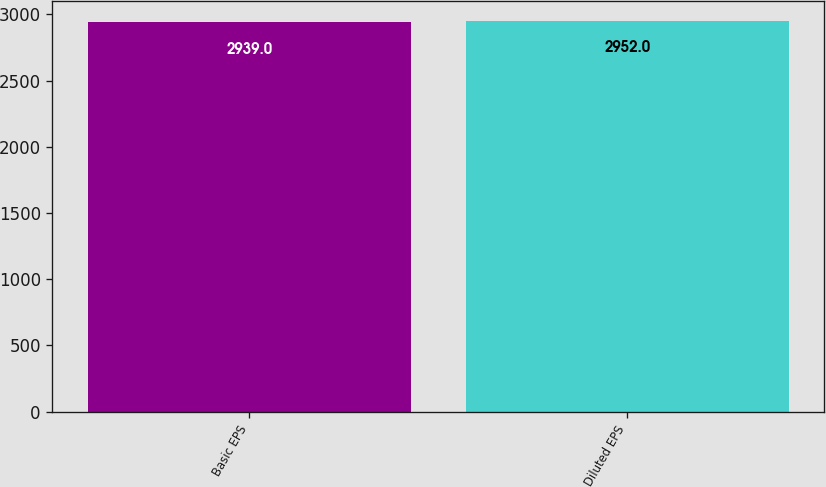Convert chart. <chart><loc_0><loc_0><loc_500><loc_500><bar_chart><fcel>Basic EPS<fcel>Diluted EPS<nl><fcel>2939<fcel>2952<nl></chart> 